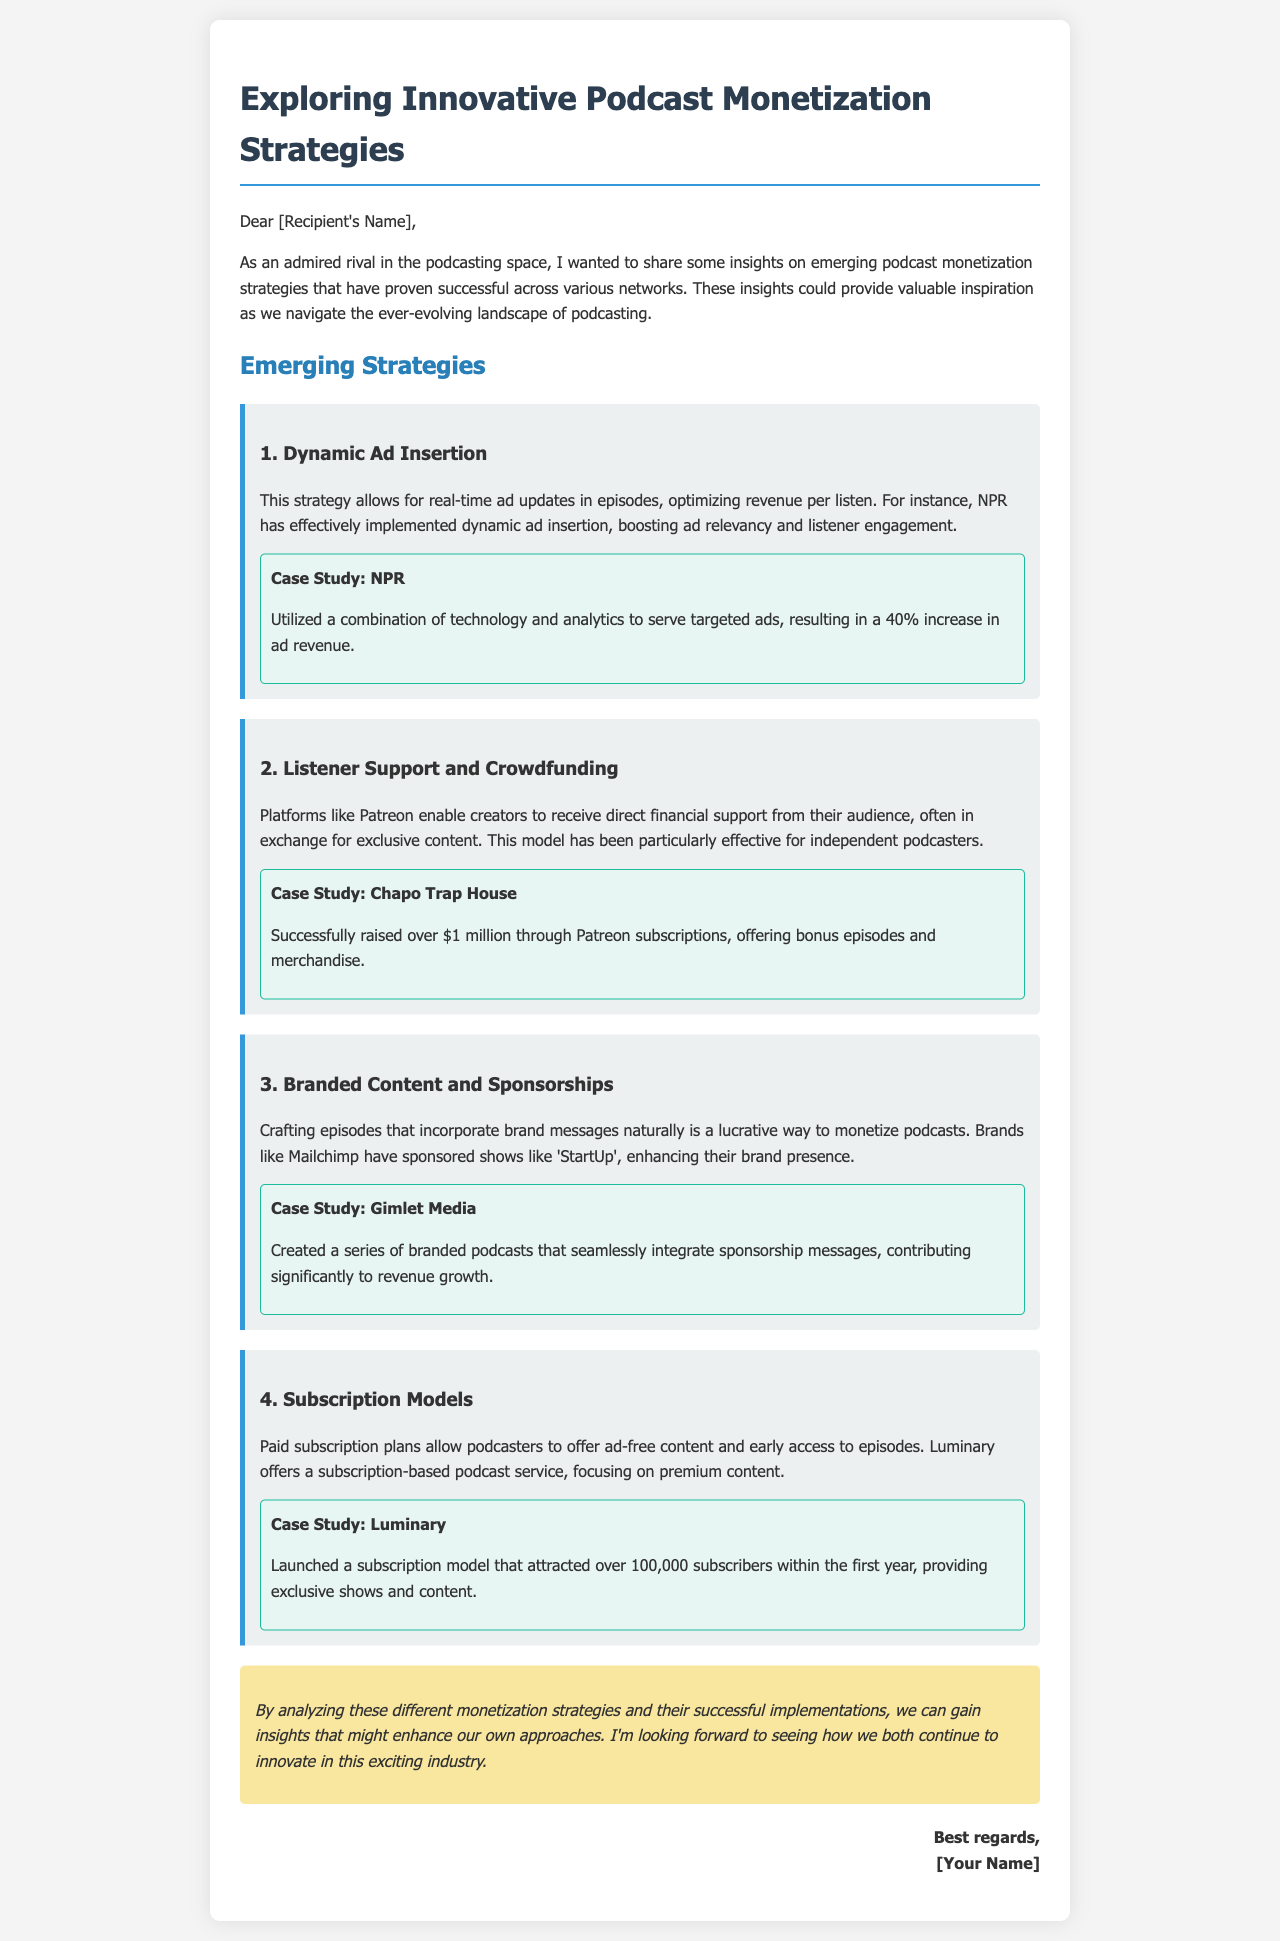What is the title of the document? The title of the document is stated clearly at the top, which is "Exploring Innovative Podcast Monetization Strategies."
Answer: Exploring Innovative Podcast Monetization Strategies Who is the case study for dynamic ad insertion? The document mentions NPR as the case study for dynamic ad insertion.
Answer: NPR What increase in ad revenue did NPR achieve? The document specifies that NPR resulted in a 40% increase in ad revenue through the use of dynamic ad insertion.
Answer: 40% How much money did Chapo Trap House raise through Patreon subscriptions? According to the document, Chapo Trap House successfully raised over $1 million through Patreon.
Answer: over $1 million What subscription model does Luminary offer? The document states that Luminary launched a subscription model allowing for ad-free content and exclusive shows.
Answer: Subscription model What type of content was created by Gimlet Media? The document notes that Gimlet Media created a series of branded podcasts integrating sponsorship messages.
Answer: Branded podcasts What are podcasters able to offer through paid subscription plans? The document indicates that paid subscription plans allow podcasters to offer ad-free content and early access to episodes.
Answer: Ad-free content and early access What does the signature at the end of the document represent? The signature at the end represents courteous closing remarks from the sender, indicating a professional interaction.
Answer: Professional interaction 